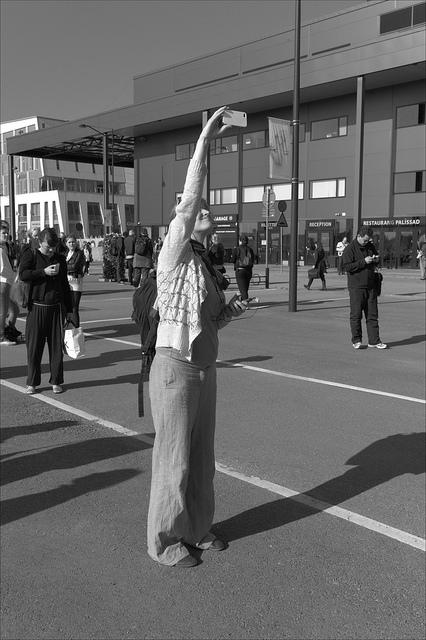What type of shoes is the woman in the foreground wearing?
Concise answer only. Sneakers. Is the lady wearing long sleeves?
Short answer required. Yes. How many people are in the street?
Concise answer only. 15. What is the lady doing?
Quick response, please. Taking picture. Is this lady wearing high heels?
Write a very short answer. No. Is this man reading a cell phone screen?
Write a very short answer. Yes. What is the person in the brown T shirt riding?
Write a very short answer. Nothing. What do the white lines on the road denote?
Answer briefly. Lanes. What is the woman toting?
Concise answer only. Backpack. Are many people playing tennis?
Quick response, please. 0. Is there a water tower?
Quick response, please. No. 